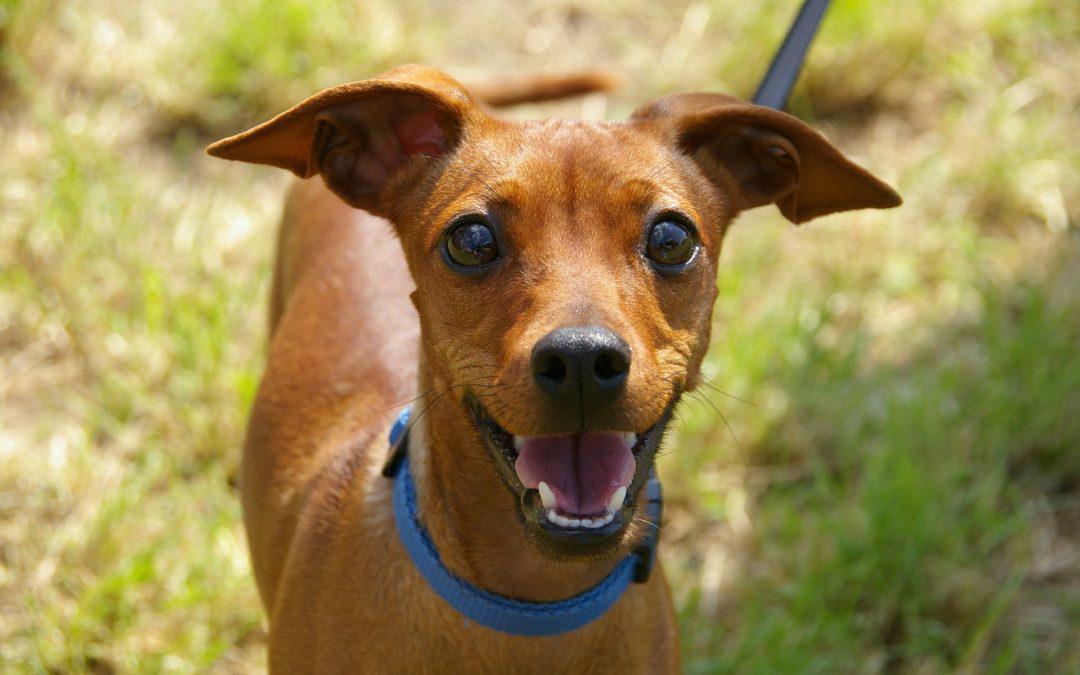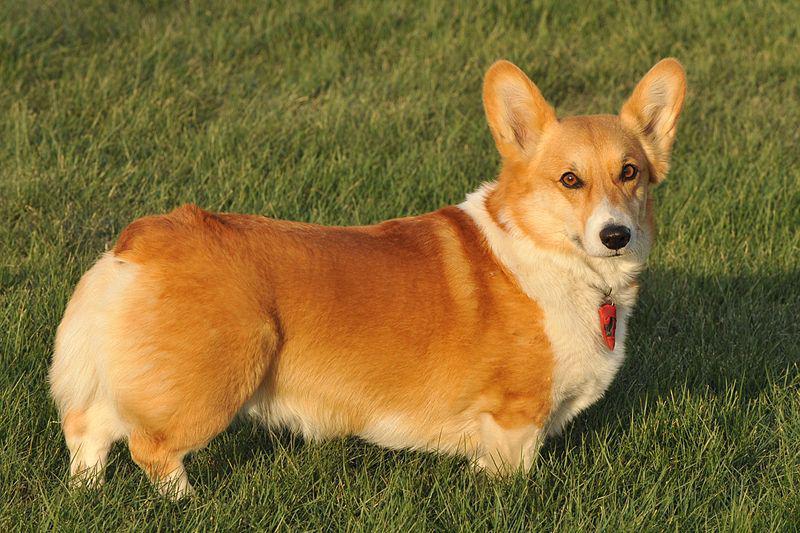The first image is the image on the left, the second image is the image on the right. For the images shown, is this caption "Exactly one dog is pointed to the right." true? Answer yes or no. Yes. The first image is the image on the left, the second image is the image on the right. For the images displayed, is the sentence "there is at least one dog with dog tags in the image pair" factually correct? Answer yes or no. Yes. 